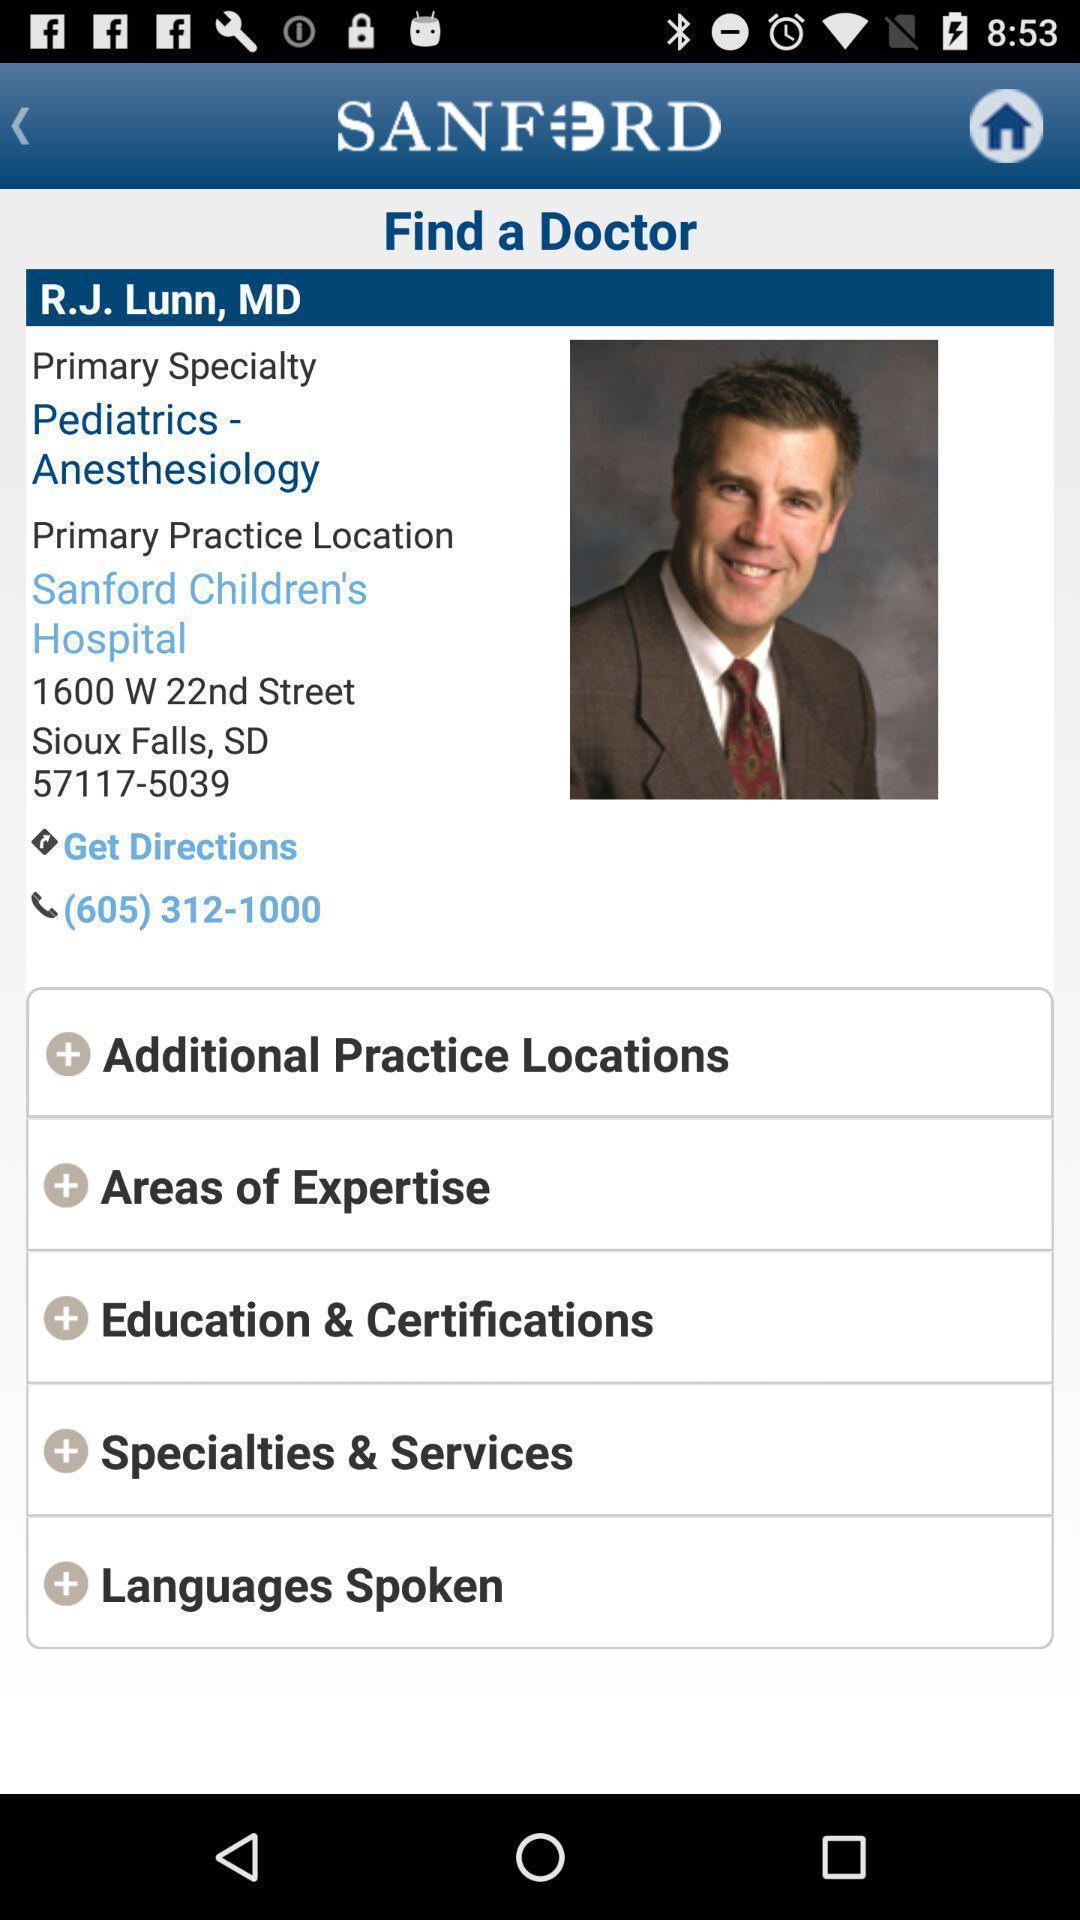Summarize the information in this screenshot. Screen page displaying doctor profile in a health application. 